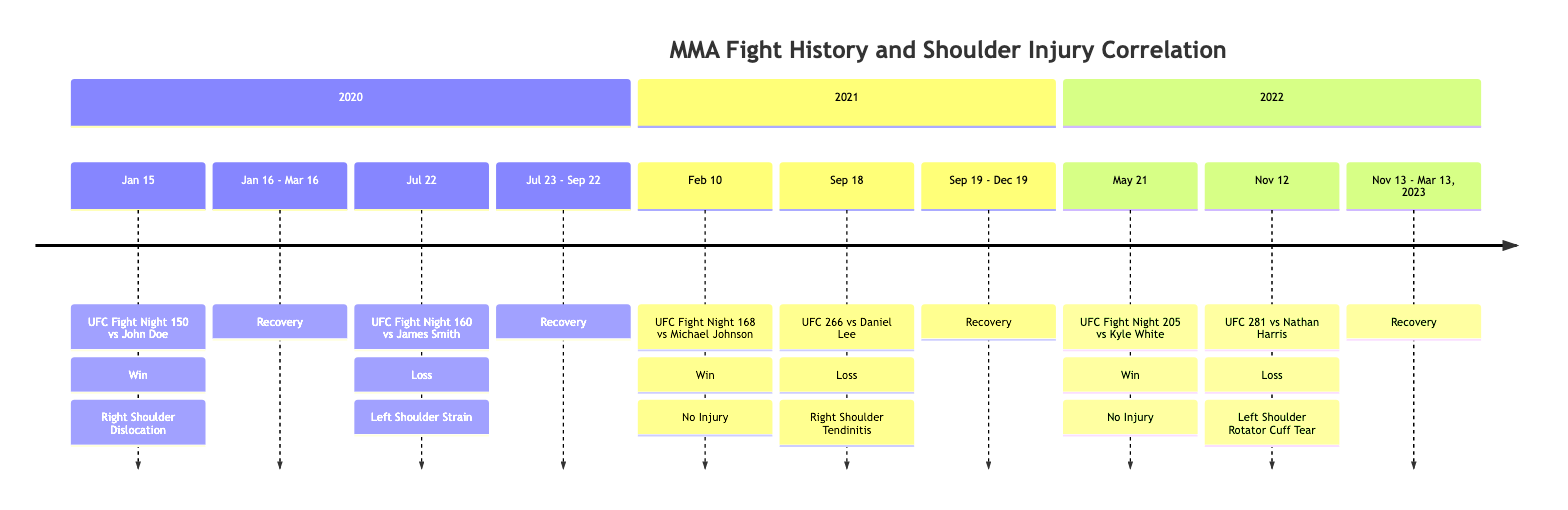What was the result of the fight on January 15, 2020? The diagram indicates that the result of the fight on January 15, 2020, against John Doe was a Win.
Answer: Win How long was the recovery for the right shoulder dislocation? The timeline shows that the recovery for the right shoulder dislocation started on January 16 and ended on March 16, which is a duration of two months.
Answer: Two months What type of injury occurred during the fight on July 22, 2020? The diagram states that during the fight on July 22, 2020, the injury type was a Left Shoulder Strain.
Answer: Left Shoulder Strain How many fights resulted in losses where an injury occurred? By examining the data, the timeline shows two fights (against James Smith on July 22, 2020, and Nathan Harris on November 12, 2022) that resulted in losses and had associated injuries.
Answer: Two fights What was the opponent for the fight on September 18, 2021? The timeline displays that the opponent for the fight on September 18, 2021, was Daniel Lee.
Answer: Daniel Lee What is the total duration of the recovery for the left shoulder rotator cuff tear? The recovery for the left shoulder rotator cuff tear started on November 13, 2022, and ended on March 13, 2023. The duration of this recovery period is four months.
Answer: Four months Which fight occurred after the injury with the right shoulder tendinitis? The timeline shows that the next fight after the injury with right shoulder tendinitis (September 18, 2021) was on May 21, 2022, against Kyle White.
Answer: May 21, 2022 How many fights had no injuries? By reviewing the timeline, there are three instances (February 10, 2021; May 21, 2022) where the fights had no injuries, leading to a total of three.
Answer: Three fights What was the last event listed in the timeline? The diagram indicates that the last event listed in the timeline was the fight against Nathan Harris on November 12, 2022.
Answer: UFC 281 